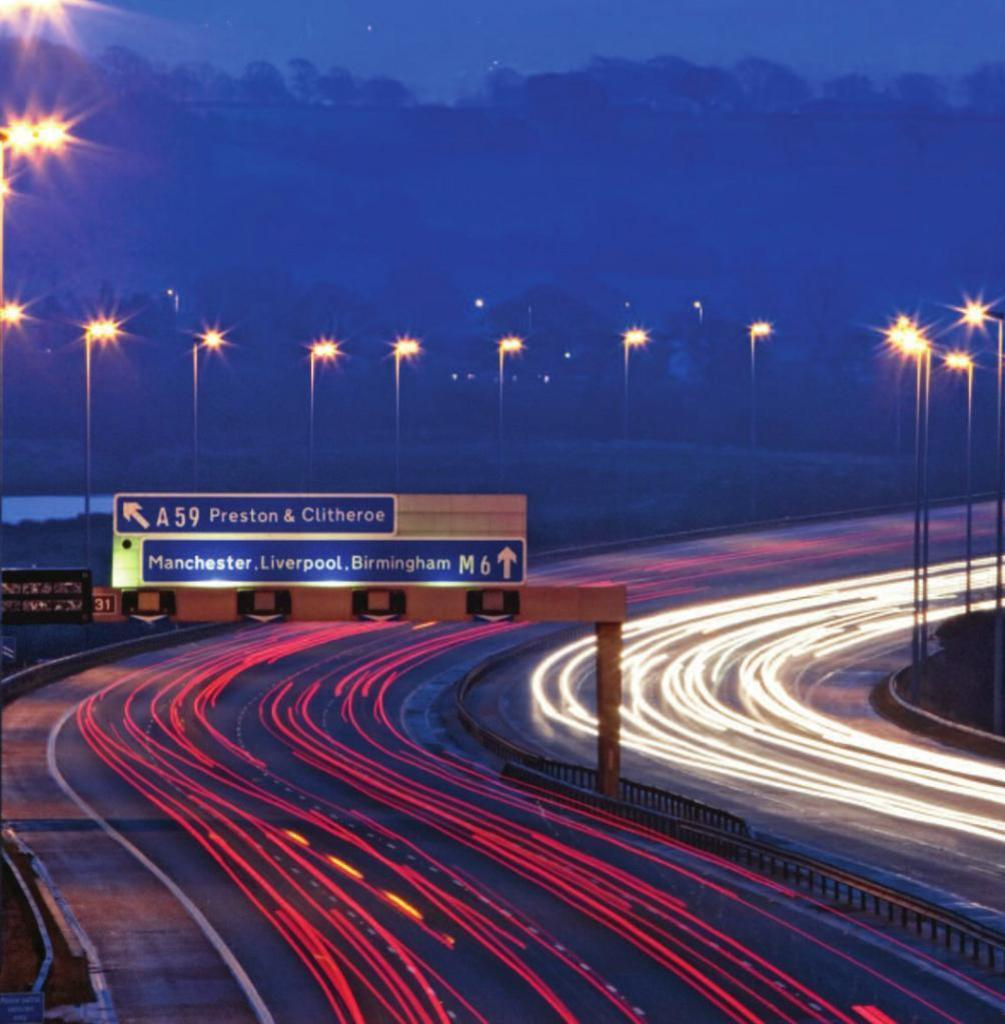What is located in the foreground of the image? There is a road, a board, and poles in the foreground of the image. What can be seen on the road in the image? There are red and white lights on the road. What is the condition of the background in the image? The background of the image is not clear. What type of sand can be seen on the record in the image? There is no record or sand present in the image. What is the weather like in the image? The provided facts do not give any information about the weather in the image. 